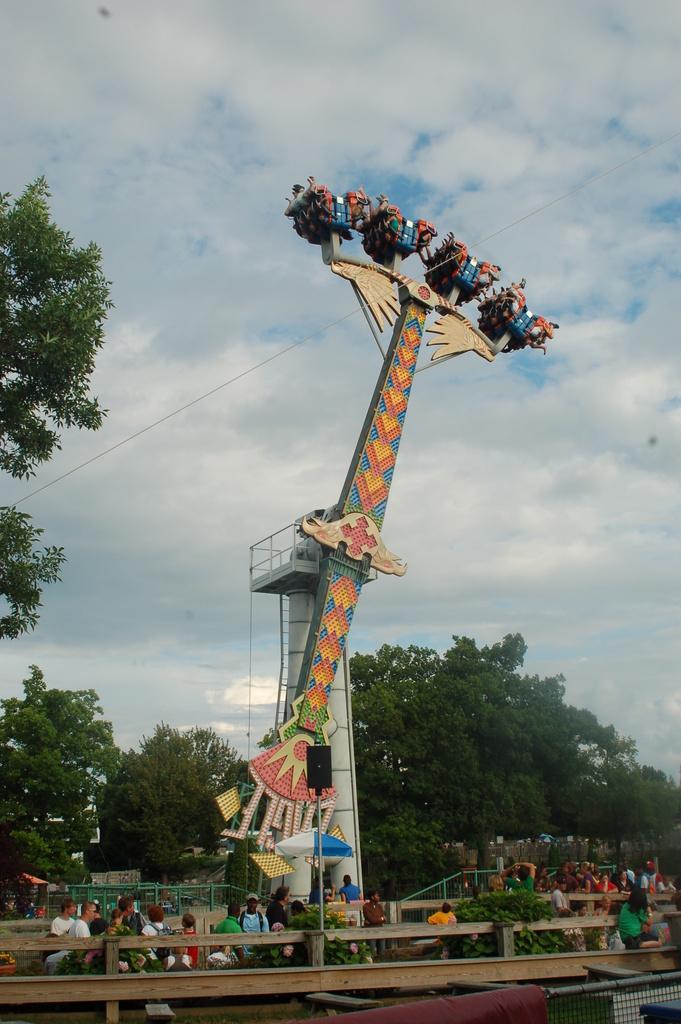Please provide a concise description of this image. In this picture we can see an amusement ride. We can see some fencing and some objects at the bottom of the picture. There are a few people, plants, an umbrella, shed and some trees are visible in the background. Sky is cloudy. 